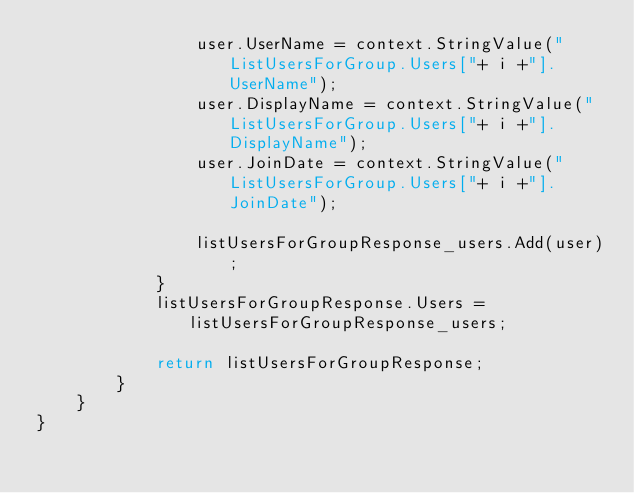<code> <loc_0><loc_0><loc_500><loc_500><_C#_>				user.UserName = context.StringValue("ListUsersForGroup.Users["+ i +"].UserName");
				user.DisplayName = context.StringValue("ListUsersForGroup.Users["+ i +"].DisplayName");
				user.JoinDate = context.StringValue("ListUsersForGroup.Users["+ i +"].JoinDate");

				listUsersForGroupResponse_users.Add(user);
			}
			listUsersForGroupResponse.Users = listUsersForGroupResponse_users;
        
			return listUsersForGroupResponse;
        }
    }
}</code> 